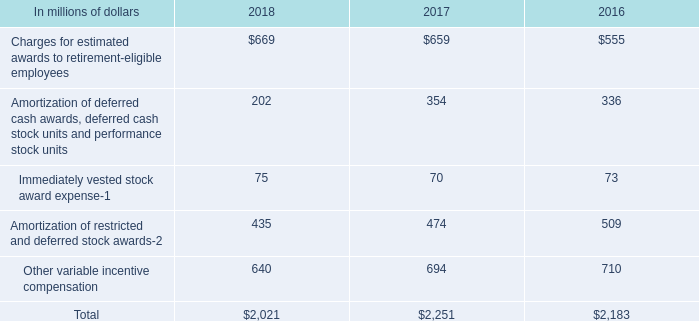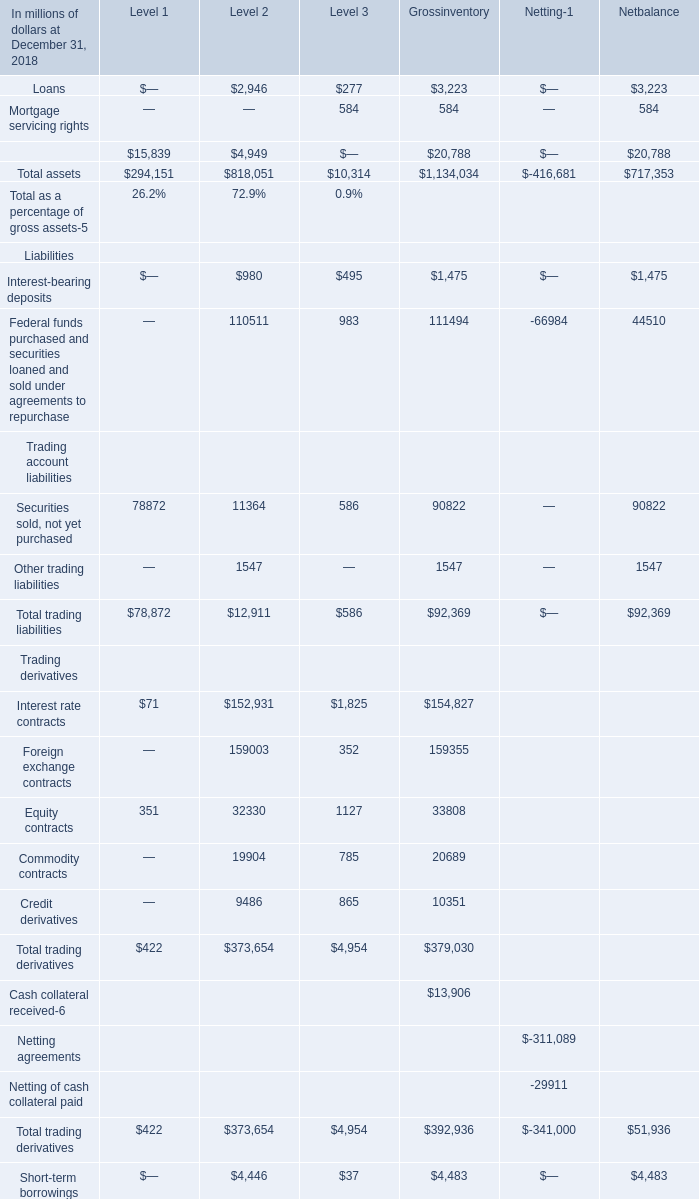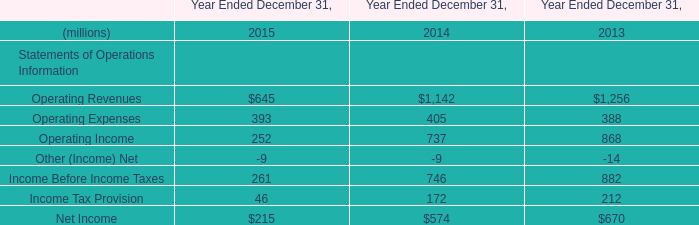In what year is Mortgage servicing rights greater than 300? 
Answer: 2018. 